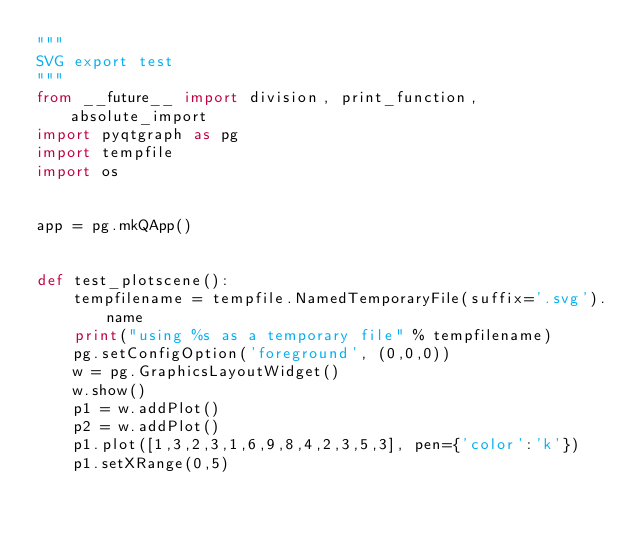Convert code to text. <code><loc_0><loc_0><loc_500><loc_500><_Python_>"""
SVG export test
"""
from __future__ import division, print_function, absolute_import
import pyqtgraph as pg
import tempfile
import os


app = pg.mkQApp()


def test_plotscene():
    tempfilename = tempfile.NamedTemporaryFile(suffix='.svg').name
    print("using %s as a temporary file" % tempfilename)
    pg.setConfigOption('foreground', (0,0,0))
    w = pg.GraphicsLayoutWidget()
    w.show()        
    p1 = w.addPlot()
    p2 = w.addPlot()
    p1.plot([1,3,2,3,1,6,9,8,4,2,3,5,3], pen={'color':'k'})
    p1.setXRange(0,5)</code> 